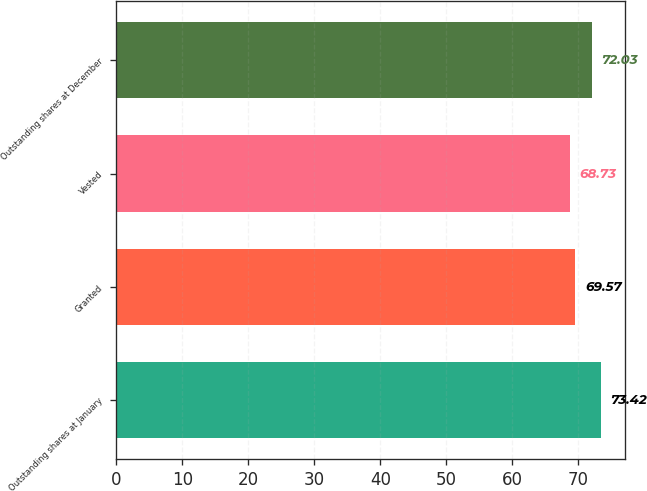<chart> <loc_0><loc_0><loc_500><loc_500><bar_chart><fcel>Outstanding shares at January<fcel>Granted<fcel>Vested<fcel>Outstanding shares at December<nl><fcel>73.42<fcel>69.57<fcel>68.73<fcel>72.03<nl></chart> 